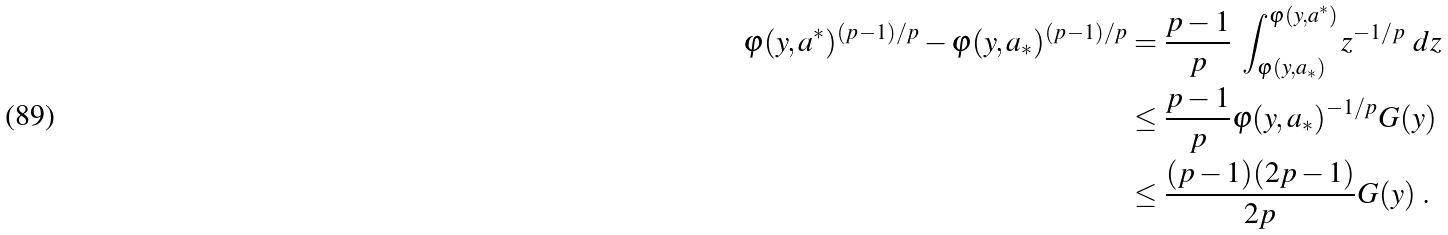Convert formula to latex. <formula><loc_0><loc_0><loc_500><loc_500>\varphi ( y , a ^ { * } ) ^ { ( p - 1 ) / p } - \varphi ( y , a _ { * } ) ^ { ( p - 1 ) / p } & = \frac { p - 1 } { p } \ \int _ { \varphi ( y , a _ { * } ) } ^ { \varphi ( y , a ^ { * } ) } z ^ { - 1 / p } \ d z \\ & \leq \frac { p - 1 } { p } \varphi ( y , a _ { * } ) ^ { - 1 / p } G ( y ) \\ & \leq \frac { ( p - 1 ) ( 2 p - 1 ) } { 2 p } G ( y ) \ .</formula> 